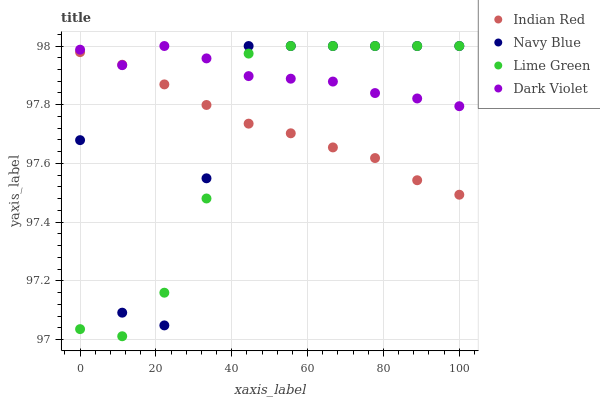Does Lime Green have the minimum area under the curve?
Answer yes or no. Yes. Does Dark Violet have the maximum area under the curve?
Answer yes or no. Yes. Does Dark Violet have the minimum area under the curve?
Answer yes or no. No. Does Lime Green have the maximum area under the curve?
Answer yes or no. No. Is Indian Red the smoothest?
Answer yes or no. Yes. Is Navy Blue the roughest?
Answer yes or no. Yes. Is Lime Green the smoothest?
Answer yes or no. No. Is Lime Green the roughest?
Answer yes or no. No. Does Lime Green have the lowest value?
Answer yes or no. Yes. Does Dark Violet have the lowest value?
Answer yes or no. No. Does Dark Violet have the highest value?
Answer yes or no. Yes. Does Indian Red have the highest value?
Answer yes or no. No. Does Dark Violet intersect Navy Blue?
Answer yes or no. Yes. Is Dark Violet less than Navy Blue?
Answer yes or no. No. Is Dark Violet greater than Navy Blue?
Answer yes or no. No. 